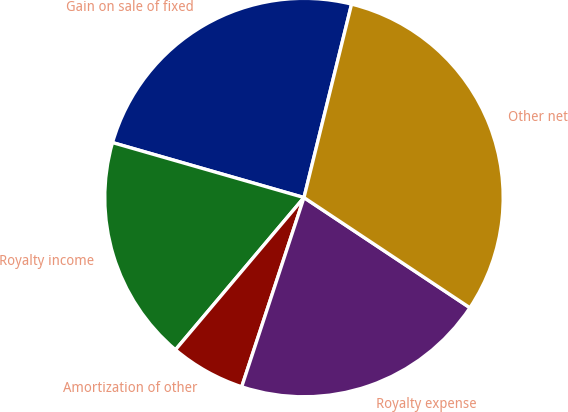Convert chart. <chart><loc_0><loc_0><loc_500><loc_500><pie_chart><fcel>Gain on sale of fixed<fcel>Royalty income<fcel>Amortization of other<fcel>Royalty expense<fcel>Other net<nl><fcel>24.39%<fcel>18.29%<fcel>6.1%<fcel>20.73%<fcel>30.49%<nl></chart> 